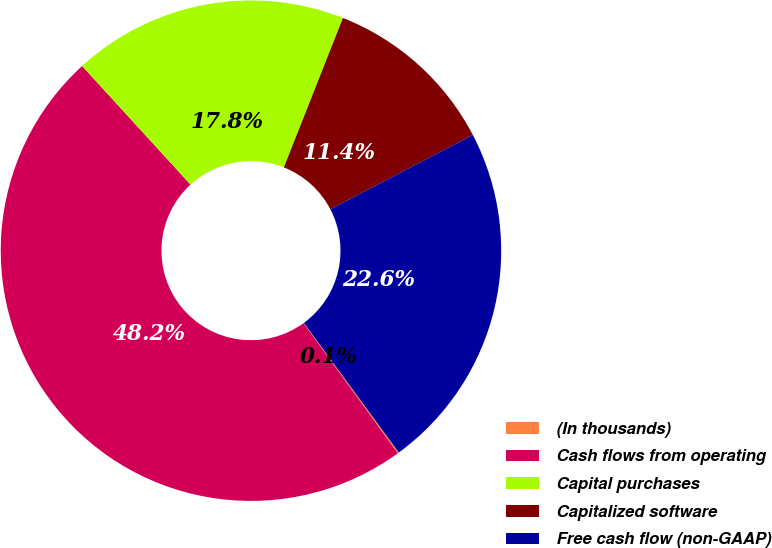<chart> <loc_0><loc_0><loc_500><loc_500><pie_chart><fcel>(In thousands)<fcel>Cash flows from operating<fcel>Capital purchases<fcel>Capitalized software<fcel>Free cash flow (non-GAAP)<nl><fcel>0.08%<fcel>48.2%<fcel>17.78%<fcel>11.36%<fcel>22.59%<nl></chart> 